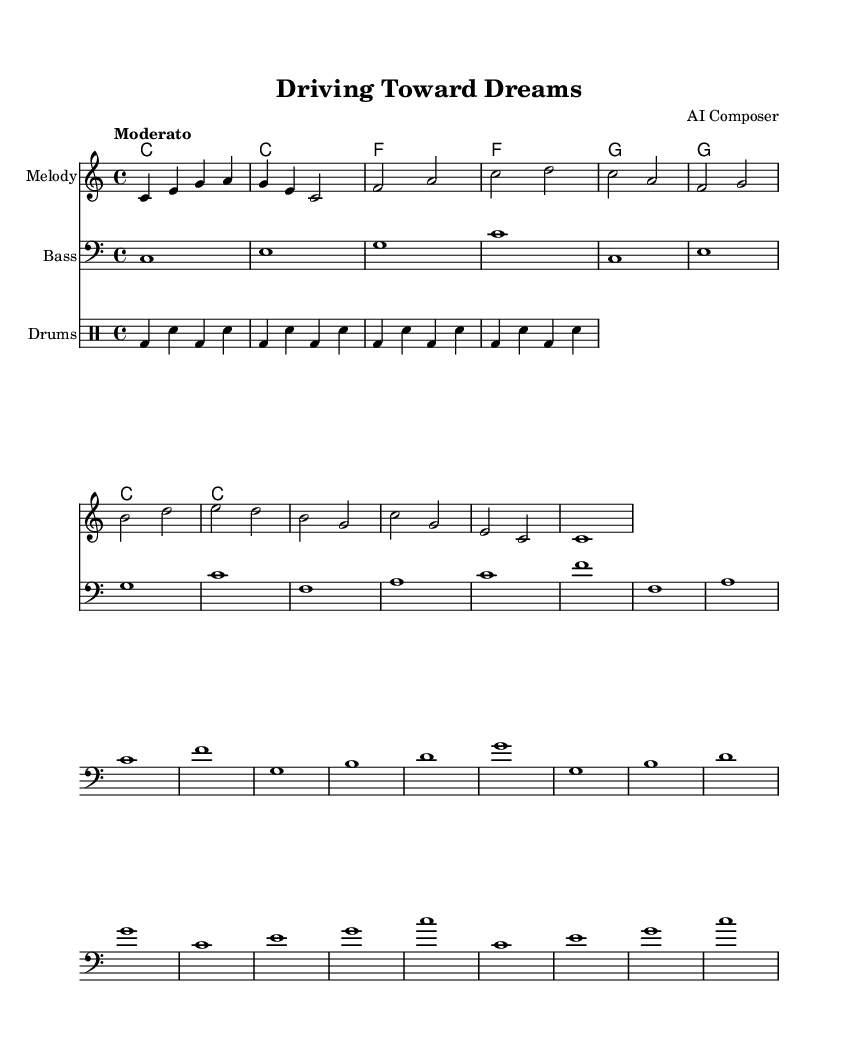What is the key signature of this music? The key signature is indicated at the beginning of the staff, showing no sharps or flats. Therefore, it is C major.
Answer: C major What is the time signature of this music? The time signature is located at the beginning of the score, which shows 4/4, indicating four beats per measure.
Answer: 4/4 What is the tempo marking for this music? The tempo marking appears at the beginning of the score as "Moderato," suggesting a moderate pace for the performance.
Answer: Moderato How many measures are in the melody part? By counting the measures in the melody staff, there are a total of 8 distinct measures shown in the notation.
Answer: 8 Which chords are used in the harmonies section? The harmonies section indicates a sequence of chords: C, F, and G, which are common in the key of C major.
Answer: C, F, G What is the rhythm pattern for the drums in the first measure? The drum part in the first measure consists of a bass drum followed by a snare, following a pattern of bass drum, snare, bass drum, and snare.
Answer: Bass, snare Which instrument has the lowest pitch in this score? The bass line is placed on the bass staff, which typically indicates the lowest pitch among the three parts. Comparing the pitches, the bass line indeed has the lowest notes.
Answer: Bass 